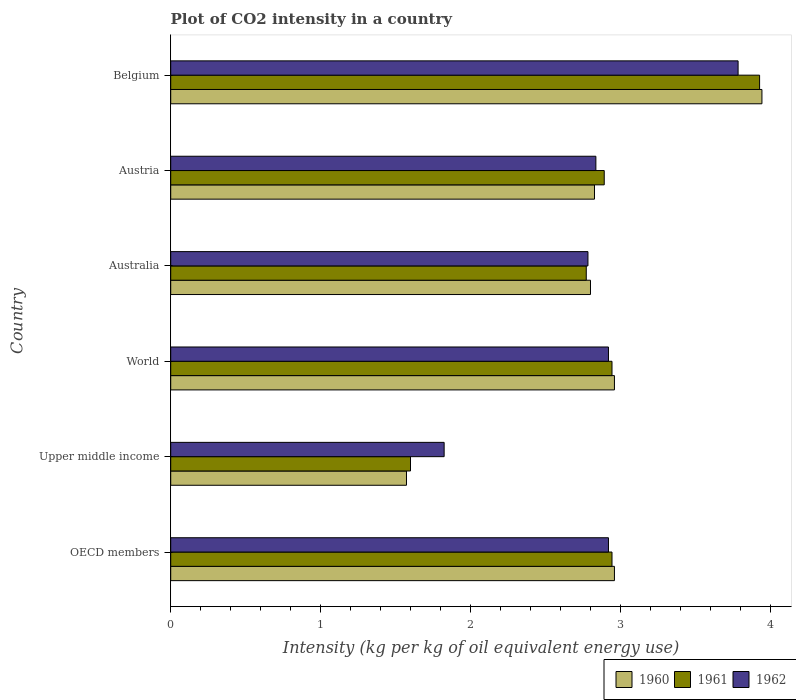How many different coloured bars are there?
Offer a terse response. 3. How many groups of bars are there?
Offer a very short reply. 6. Are the number of bars on each tick of the Y-axis equal?
Provide a succinct answer. Yes. How many bars are there on the 1st tick from the top?
Your answer should be very brief. 3. How many bars are there on the 6th tick from the bottom?
Your response must be concise. 3. What is the label of the 5th group of bars from the top?
Your answer should be compact. Upper middle income. What is the CO2 intensity in in 1962 in Belgium?
Your answer should be very brief. 3.79. Across all countries, what is the maximum CO2 intensity in in 1962?
Your answer should be very brief. 3.79. Across all countries, what is the minimum CO2 intensity in in 1960?
Provide a succinct answer. 1.57. In which country was the CO2 intensity in in 1961 minimum?
Your response must be concise. Upper middle income. What is the total CO2 intensity in in 1962 in the graph?
Offer a very short reply. 17.08. What is the difference between the CO2 intensity in in 1960 in Upper middle income and that in World?
Make the answer very short. -1.39. What is the difference between the CO2 intensity in in 1960 in Austria and the CO2 intensity in in 1962 in Belgium?
Your answer should be compact. -0.96. What is the average CO2 intensity in in 1961 per country?
Keep it short and to the point. 2.85. What is the difference between the CO2 intensity in in 1960 and CO2 intensity in in 1962 in Australia?
Make the answer very short. 0.02. What is the ratio of the CO2 intensity in in 1960 in Australia to that in Belgium?
Provide a succinct answer. 0.71. Is the CO2 intensity in in 1960 in Upper middle income less than that in World?
Make the answer very short. Yes. What is the difference between the highest and the second highest CO2 intensity in in 1961?
Make the answer very short. 0.99. What is the difference between the highest and the lowest CO2 intensity in in 1962?
Your answer should be very brief. 1.96. Is the sum of the CO2 intensity in in 1960 in Belgium and OECD members greater than the maximum CO2 intensity in in 1961 across all countries?
Make the answer very short. Yes. What does the 2nd bar from the top in Belgium represents?
Offer a very short reply. 1961. Is it the case that in every country, the sum of the CO2 intensity in in 1962 and CO2 intensity in in 1960 is greater than the CO2 intensity in in 1961?
Ensure brevity in your answer.  Yes. How many bars are there?
Make the answer very short. 18. Are all the bars in the graph horizontal?
Your answer should be very brief. Yes. How many countries are there in the graph?
Your answer should be very brief. 6. What is the difference between two consecutive major ticks on the X-axis?
Keep it short and to the point. 1. Are the values on the major ticks of X-axis written in scientific E-notation?
Offer a very short reply. No. Does the graph contain any zero values?
Give a very brief answer. No. What is the title of the graph?
Give a very brief answer. Plot of CO2 intensity in a country. Does "1998" appear as one of the legend labels in the graph?
Your response must be concise. No. What is the label or title of the X-axis?
Provide a succinct answer. Intensity (kg per kg of oil equivalent energy use). What is the Intensity (kg per kg of oil equivalent energy use) of 1960 in OECD members?
Your answer should be compact. 2.96. What is the Intensity (kg per kg of oil equivalent energy use) of 1961 in OECD members?
Make the answer very short. 2.95. What is the Intensity (kg per kg of oil equivalent energy use) of 1962 in OECD members?
Offer a very short reply. 2.92. What is the Intensity (kg per kg of oil equivalent energy use) of 1960 in Upper middle income?
Provide a short and direct response. 1.57. What is the Intensity (kg per kg of oil equivalent energy use) of 1961 in Upper middle income?
Your answer should be very brief. 1.6. What is the Intensity (kg per kg of oil equivalent energy use) of 1962 in Upper middle income?
Offer a terse response. 1.82. What is the Intensity (kg per kg of oil equivalent energy use) in 1960 in World?
Offer a very short reply. 2.96. What is the Intensity (kg per kg of oil equivalent energy use) in 1961 in World?
Your answer should be compact. 2.95. What is the Intensity (kg per kg of oil equivalent energy use) of 1962 in World?
Your response must be concise. 2.92. What is the Intensity (kg per kg of oil equivalent energy use) of 1960 in Australia?
Your answer should be compact. 2.8. What is the Intensity (kg per kg of oil equivalent energy use) of 1961 in Australia?
Your response must be concise. 2.77. What is the Intensity (kg per kg of oil equivalent energy use) of 1962 in Australia?
Your answer should be very brief. 2.78. What is the Intensity (kg per kg of oil equivalent energy use) of 1960 in Austria?
Offer a terse response. 2.83. What is the Intensity (kg per kg of oil equivalent energy use) in 1961 in Austria?
Offer a very short reply. 2.89. What is the Intensity (kg per kg of oil equivalent energy use) of 1962 in Austria?
Provide a succinct answer. 2.84. What is the Intensity (kg per kg of oil equivalent energy use) of 1960 in Belgium?
Provide a succinct answer. 3.95. What is the Intensity (kg per kg of oil equivalent energy use) in 1961 in Belgium?
Your answer should be very brief. 3.93. What is the Intensity (kg per kg of oil equivalent energy use) in 1962 in Belgium?
Your response must be concise. 3.79. Across all countries, what is the maximum Intensity (kg per kg of oil equivalent energy use) in 1960?
Your answer should be compact. 3.95. Across all countries, what is the maximum Intensity (kg per kg of oil equivalent energy use) of 1961?
Give a very brief answer. 3.93. Across all countries, what is the maximum Intensity (kg per kg of oil equivalent energy use) in 1962?
Give a very brief answer. 3.79. Across all countries, what is the minimum Intensity (kg per kg of oil equivalent energy use) of 1960?
Keep it short and to the point. 1.57. Across all countries, what is the minimum Intensity (kg per kg of oil equivalent energy use) in 1961?
Make the answer very short. 1.6. Across all countries, what is the minimum Intensity (kg per kg of oil equivalent energy use) in 1962?
Your response must be concise. 1.82. What is the total Intensity (kg per kg of oil equivalent energy use) in 1960 in the graph?
Keep it short and to the point. 17.07. What is the total Intensity (kg per kg of oil equivalent energy use) of 1961 in the graph?
Your answer should be very brief. 17.09. What is the total Intensity (kg per kg of oil equivalent energy use) in 1962 in the graph?
Make the answer very short. 17.08. What is the difference between the Intensity (kg per kg of oil equivalent energy use) of 1960 in OECD members and that in Upper middle income?
Give a very brief answer. 1.39. What is the difference between the Intensity (kg per kg of oil equivalent energy use) in 1961 in OECD members and that in Upper middle income?
Keep it short and to the point. 1.34. What is the difference between the Intensity (kg per kg of oil equivalent energy use) of 1962 in OECD members and that in Upper middle income?
Offer a terse response. 1.1. What is the difference between the Intensity (kg per kg of oil equivalent energy use) in 1961 in OECD members and that in World?
Keep it short and to the point. 0. What is the difference between the Intensity (kg per kg of oil equivalent energy use) of 1960 in OECD members and that in Australia?
Provide a short and direct response. 0.16. What is the difference between the Intensity (kg per kg of oil equivalent energy use) in 1961 in OECD members and that in Australia?
Provide a short and direct response. 0.17. What is the difference between the Intensity (kg per kg of oil equivalent energy use) in 1962 in OECD members and that in Australia?
Your response must be concise. 0.14. What is the difference between the Intensity (kg per kg of oil equivalent energy use) of 1960 in OECD members and that in Austria?
Keep it short and to the point. 0.13. What is the difference between the Intensity (kg per kg of oil equivalent energy use) in 1961 in OECD members and that in Austria?
Your answer should be very brief. 0.05. What is the difference between the Intensity (kg per kg of oil equivalent energy use) of 1962 in OECD members and that in Austria?
Give a very brief answer. 0.08. What is the difference between the Intensity (kg per kg of oil equivalent energy use) of 1960 in OECD members and that in Belgium?
Offer a very short reply. -0.98. What is the difference between the Intensity (kg per kg of oil equivalent energy use) of 1961 in OECD members and that in Belgium?
Give a very brief answer. -0.99. What is the difference between the Intensity (kg per kg of oil equivalent energy use) of 1962 in OECD members and that in Belgium?
Make the answer very short. -0.87. What is the difference between the Intensity (kg per kg of oil equivalent energy use) of 1960 in Upper middle income and that in World?
Offer a very short reply. -1.39. What is the difference between the Intensity (kg per kg of oil equivalent energy use) of 1961 in Upper middle income and that in World?
Your response must be concise. -1.34. What is the difference between the Intensity (kg per kg of oil equivalent energy use) of 1962 in Upper middle income and that in World?
Your response must be concise. -1.1. What is the difference between the Intensity (kg per kg of oil equivalent energy use) of 1960 in Upper middle income and that in Australia?
Provide a succinct answer. -1.23. What is the difference between the Intensity (kg per kg of oil equivalent energy use) of 1961 in Upper middle income and that in Australia?
Offer a terse response. -1.17. What is the difference between the Intensity (kg per kg of oil equivalent energy use) of 1962 in Upper middle income and that in Australia?
Offer a very short reply. -0.96. What is the difference between the Intensity (kg per kg of oil equivalent energy use) in 1960 in Upper middle income and that in Austria?
Your answer should be compact. -1.25. What is the difference between the Intensity (kg per kg of oil equivalent energy use) in 1961 in Upper middle income and that in Austria?
Provide a short and direct response. -1.29. What is the difference between the Intensity (kg per kg of oil equivalent energy use) in 1962 in Upper middle income and that in Austria?
Your answer should be very brief. -1.01. What is the difference between the Intensity (kg per kg of oil equivalent energy use) in 1960 in Upper middle income and that in Belgium?
Keep it short and to the point. -2.37. What is the difference between the Intensity (kg per kg of oil equivalent energy use) in 1961 in Upper middle income and that in Belgium?
Your answer should be compact. -2.33. What is the difference between the Intensity (kg per kg of oil equivalent energy use) in 1962 in Upper middle income and that in Belgium?
Offer a very short reply. -1.96. What is the difference between the Intensity (kg per kg of oil equivalent energy use) of 1960 in World and that in Australia?
Keep it short and to the point. 0.16. What is the difference between the Intensity (kg per kg of oil equivalent energy use) in 1961 in World and that in Australia?
Offer a terse response. 0.17. What is the difference between the Intensity (kg per kg of oil equivalent energy use) in 1962 in World and that in Australia?
Provide a succinct answer. 0.14. What is the difference between the Intensity (kg per kg of oil equivalent energy use) in 1960 in World and that in Austria?
Make the answer very short. 0.13. What is the difference between the Intensity (kg per kg of oil equivalent energy use) of 1961 in World and that in Austria?
Give a very brief answer. 0.05. What is the difference between the Intensity (kg per kg of oil equivalent energy use) of 1962 in World and that in Austria?
Ensure brevity in your answer.  0.08. What is the difference between the Intensity (kg per kg of oil equivalent energy use) in 1960 in World and that in Belgium?
Make the answer very short. -0.98. What is the difference between the Intensity (kg per kg of oil equivalent energy use) in 1961 in World and that in Belgium?
Ensure brevity in your answer.  -0.99. What is the difference between the Intensity (kg per kg of oil equivalent energy use) of 1962 in World and that in Belgium?
Keep it short and to the point. -0.87. What is the difference between the Intensity (kg per kg of oil equivalent energy use) in 1960 in Australia and that in Austria?
Make the answer very short. -0.03. What is the difference between the Intensity (kg per kg of oil equivalent energy use) of 1961 in Australia and that in Austria?
Your response must be concise. -0.12. What is the difference between the Intensity (kg per kg of oil equivalent energy use) of 1962 in Australia and that in Austria?
Your answer should be compact. -0.05. What is the difference between the Intensity (kg per kg of oil equivalent energy use) in 1960 in Australia and that in Belgium?
Your response must be concise. -1.14. What is the difference between the Intensity (kg per kg of oil equivalent energy use) of 1961 in Australia and that in Belgium?
Keep it short and to the point. -1.16. What is the difference between the Intensity (kg per kg of oil equivalent energy use) of 1962 in Australia and that in Belgium?
Your answer should be compact. -1. What is the difference between the Intensity (kg per kg of oil equivalent energy use) in 1960 in Austria and that in Belgium?
Your answer should be compact. -1.12. What is the difference between the Intensity (kg per kg of oil equivalent energy use) of 1961 in Austria and that in Belgium?
Provide a short and direct response. -1.04. What is the difference between the Intensity (kg per kg of oil equivalent energy use) of 1962 in Austria and that in Belgium?
Provide a short and direct response. -0.95. What is the difference between the Intensity (kg per kg of oil equivalent energy use) in 1960 in OECD members and the Intensity (kg per kg of oil equivalent energy use) in 1961 in Upper middle income?
Offer a terse response. 1.36. What is the difference between the Intensity (kg per kg of oil equivalent energy use) of 1960 in OECD members and the Intensity (kg per kg of oil equivalent energy use) of 1962 in Upper middle income?
Offer a terse response. 1.14. What is the difference between the Intensity (kg per kg of oil equivalent energy use) of 1961 in OECD members and the Intensity (kg per kg of oil equivalent energy use) of 1962 in Upper middle income?
Provide a short and direct response. 1.12. What is the difference between the Intensity (kg per kg of oil equivalent energy use) of 1960 in OECD members and the Intensity (kg per kg of oil equivalent energy use) of 1961 in World?
Provide a succinct answer. 0.02. What is the difference between the Intensity (kg per kg of oil equivalent energy use) in 1960 in OECD members and the Intensity (kg per kg of oil equivalent energy use) in 1962 in World?
Provide a short and direct response. 0.04. What is the difference between the Intensity (kg per kg of oil equivalent energy use) of 1961 in OECD members and the Intensity (kg per kg of oil equivalent energy use) of 1962 in World?
Offer a terse response. 0.02. What is the difference between the Intensity (kg per kg of oil equivalent energy use) in 1960 in OECD members and the Intensity (kg per kg of oil equivalent energy use) in 1961 in Australia?
Ensure brevity in your answer.  0.19. What is the difference between the Intensity (kg per kg of oil equivalent energy use) of 1960 in OECD members and the Intensity (kg per kg of oil equivalent energy use) of 1962 in Australia?
Make the answer very short. 0.18. What is the difference between the Intensity (kg per kg of oil equivalent energy use) in 1961 in OECD members and the Intensity (kg per kg of oil equivalent energy use) in 1962 in Australia?
Offer a terse response. 0.16. What is the difference between the Intensity (kg per kg of oil equivalent energy use) in 1960 in OECD members and the Intensity (kg per kg of oil equivalent energy use) in 1961 in Austria?
Offer a terse response. 0.07. What is the difference between the Intensity (kg per kg of oil equivalent energy use) in 1960 in OECD members and the Intensity (kg per kg of oil equivalent energy use) in 1962 in Austria?
Ensure brevity in your answer.  0.12. What is the difference between the Intensity (kg per kg of oil equivalent energy use) of 1961 in OECD members and the Intensity (kg per kg of oil equivalent energy use) of 1962 in Austria?
Ensure brevity in your answer.  0.11. What is the difference between the Intensity (kg per kg of oil equivalent energy use) in 1960 in OECD members and the Intensity (kg per kg of oil equivalent energy use) in 1961 in Belgium?
Your answer should be very brief. -0.97. What is the difference between the Intensity (kg per kg of oil equivalent energy use) of 1960 in OECD members and the Intensity (kg per kg of oil equivalent energy use) of 1962 in Belgium?
Ensure brevity in your answer.  -0.83. What is the difference between the Intensity (kg per kg of oil equivalent energy use) of 1961 in OECD members and the Intensity (kg per kg of oil equivalent energy use) of 1962 in Belgium?
Your answer should be very brief. -0.84. What is the difference between the Intensity (kg per kg of oil equivalent energy use) of 1960 in Upper middle income and the Intensity (kg per kg of oil equivalent energy use) of 1961 in World?
Offer a terse response. -1.37. What is the difference between the Intensity (kg per kg of oil equivalent energy use) in 1960 in Upper middle income and the Intensity (kg per kg of oil equivalent energy use) in 1962 in World?
Your answer should be compact. -1.35. What is the difference between the Intensity (kg per kg of oil equivalent energy use) of 1961 in Upper middle income and the Intensity (kg per kg of oil equivalent energy use) of 1962 in World?
Make the answer very short. -1.32. What is the difference between the Intensity (kg per kg of oil equivalent energy use) in 1960 in Upper middle income and the Intensity (kg per kg of oil equivalent energy use) in 1962 in Australia?
Your answer should be very brief. -1.21. What is the difference between the Intensity (kg per kg of oil equivalent energy use) of 1961 in Upper middle income and the Intensity (kg per kg of oil equivalent energy use) of 1962 in Australia?
Offer a very short reply. -1.18. What is the difference between the Intensity (kg per kg of oil equivalent energy use) in 1960 in Upper middle income and the Intensity (kg per kg of oil equivalent energy use) in 1961 in Austria?
Make the answer very short. -1.32. What is the difference between the Intensity (kg per kg of oil equivalent energy use) of 1960 in Upper middle income and the Intensity (kg per kg of oil equivalent energy use) of 1962 in Austria?
Offer a terse response. -1.26. What is the difference between the Intensity (kg per kg of oil equivalent energy use) of 1961 in Upper middle income and the Intensity (kg per kg of oil equivalent energy use) of 1962 in Austria?
Provide a succinct answer. -1.24. What is the difference between the Intensity (kg per kg of oil equivalent energy use) of 1960 in Upper middle income and the Intensity (kg per kg of oil equivalent energy use) of 1961 in Belgium?
Keep it short and to the point. -2.36. What is the difference between the Intensity (kg per kg of oil equivalent energy use) in 1960 in Upper middle income and the Intensity (kg per kg of oil equivalent energy use) in 1962 in Belgium?
Offer a terse response. -2.21. What is the difference between the Intensity (kg per kg of oil equivalent energy use) of 1961 in Upper middle income and the Intensity (kg per kg of oil equivalent energy use) of 1962 in Belgium?
Your answer should be very brief. -2.19. What is the difference between the Intensity (kg per kg of oil equivalent energy use) of 1960 in World and the Intensity (kg per kg of oil equivalent energy use) of 1961 in Australia?
Your response must be concise. 0.19. What is the difference between the Intensity (kg per kg of oil equivalent energy use) of 1960 in World and the Intensity (kg per kg of oil equivalent energy use) of 1962 in Australia?
Provide a short and direct response. 0.18. What is the difference between the Intensity (kg per kg of oil equivalent energy use) in 1961 in World and the Intensity (kg per kg of oil equivalent energy use) in 1962 in Australia?
Your response must be concise. 0.16. What is the difference between the Intensity (kg per kg of oil equivalent energy use) in 1960 in World and the Intensity (kg per kg of oil equivalent energy use) in 1961 in Austria?
Ensure brevity in your answer.  0.07. What is the difference between the Intensity (kg per kg of oil equivalent energy use) of 1960 in World and the Intensity (kg per kg of oil equivalent energy use) of 1962 in Austria?
Give a very brief answer. 0.12. What is the difference between the Intensity (kg per kg of oil equivalent energy use) in 1961 in World and the Intensity (kg per kg of oil equivalent energy use) in 1962 in Austria?
Your answer should be very brief. 0.11. What is the difference between the Intensity (kg per kg of oil equivalent energy use) in 1960 in World and the Intensity (kg per kg of oil equivalent energy use) in 1961 in Belgium?
Offer a terse response. -0.97. What is the difference between the Intensity (kg per kg of oil equivalent energy use) of 1960 in World and the Intensity (kg per kg of oil equivalent energy use) of 1962 in Belgium?
Your answer should be very brief. -0.83. What is the difference between the Intensity (kg per kg of oil equivalent energy use) in 1961 in World and the Intensity (kg per kg of oil equivalent energy use) in 1962 in Belgium?
Offer a very short reply. -0.84. What is the difference between the Intensity (kg per kg of oil equivalent energy use) of 1960 in Australia and the Intensity (kg per kg of oil equivalent energy use) of 1961 in Austria?
Make the answer very short. -0.09. What is the difference between the Intensity (kg per kg of oil equivalent energy use) in 1960 in Australia and the Intensity (kg per kg of oil equivalent energy use) in 1962 in Austria?
Provide a short and direct response. -0.04. What is the difference between the Intensity (kg per kg of oil equivalent energy use) in 1961 in Australia and the Intensity (kg per kg of oil equivalent energy use) in 1962 in Austria?
Your answer should be compact. -0.06. What is the difference between the Intensity (kg per kg of oil equivalent energy use) of 1960 in Australia and the Intensity (kg per kg of oil equivalent energy use) of 1961 in Belgium?
Make the answer very short. -1.13. What is the difference between the Intensity (kg per kg of oil equivalent energy use) of 1960 in Australia and the Intensity (kg per kg of oil equivalent energy use) of 1962 in Belgium?
Your answer should be very brief. -0.99. What is the difference between the Intensity (kg per kg of oil equivalent energy use) of 1961 in Australia and the Intensity (kg per kg of oil equivalent energy use) of 1962 in Belgium?
Provide a succinct answer. -1.01. What is the difference between the Intensity (kg per kg of oil equivalent energy use) of 1960 in Austria and the Intensity (kg per kg of oil equivalent energy use) of 1961 in Belgium?
Provide a succinct answer. -1.1. What is the difference between the Intensity (kg per kg of oil equivalent energy use) of 1960 in Austria and the Intensity (kg per kg of oil equivalent energy use) of 1962 in Belgium?
Ensure brevity in your answer.  -0.96. What is the difference between the Intensity (kg per kg of oil equivalent energy use) of 1961 in Austria and the Intensity (kg per kg of oil equivalent energy use) of 1962 in Belgium?
Offer a terse response. -0.89. What is the average Intensity (kg per kg of oil equivalent energy use) of 1960 per country?
Your answer should be very brief. 2.85. What is the average Intensity (kg per kg of oil equivalent energy use) in 1961 per country?
Make the answer very short. 2.85. What is the average Intensity (kg per kg of oil equivalent energy use) of 1962 per country?
Provide a succinct answer. 2.85. What is the difference between the Intensity (kg per kg of oil equivalent energy use) in 1960 and Intensity (kg per kg of oil equivalent energy use) in 1961 in OECD members?
Make the answer very short. 0.02. What is the difference between the Intensity (kg per kg of oil equivalent energy use) of 1960 and Intensity (kg per kg of oil equivalent energy use) of 1962 in OECD members?
Your answer should be compact. 0.04. What is the difference between the Intensity (kg per kg of oil equivalent energy use) in 1961 and Intensity (kg per kg of oil equivalent energy use) in 1962 in OECD members?
Provide a short and direct response. 0.02. What is the difference between the Intensity (kg per kg of oil equivalent energy use) in 1960 and Intensity (kg per kg of oil equivalent energy use) in 1961 in Upper middle income?
Keep it short and to the point. -0.03. What is the difference between the Intensity (kg per kg of oil equivalent energy use) of 1960 and Intensity (kg per kg of oil equivalent energy use) of 1962 in Upper middle income?
Provide a short and direct response. -0.25. What is the difference between the Intensity (kg per kg of oil equivalent energy use) in 1961 and Intensity (kg per kg of oil equivalent energy use) in 1962 in Upper middle income?
Offer a terse response. -0.22. What is the difference between the Intensity (kg per kg of oil equivalent energy use) of 1960 and Intensity (kg per kg of oil equivalent energy use) of 1961 in World?
Your answer should be very brief. 0.02. What is the difference between the Intensity (kg per kg of oil equivalent energy use) of 1960 and Intensity (kg per kg of oil equivalent energy use) of 1962 in World?
Provide a short and direct response. 0.04. What is the difference between the Intensity (kg per kg of oil equivalent energy use) of 1961 and Intensity (kg per kg of oil equivalent energy use) of 1962 in World?
Make the answer very short. 0.02. What is the difference between the Intensity (kg per kg of oil equivalent energy use) in 1960 and Intensity (kg per kg of oil equivalent energy use) in 1961 in Australia?
Ensure brevity in your answer.  0.03. What is the difference between the Intensity (kg per kg of oil equivalent energy use) in 1960 and Intensity (kg per kg of oil equivalent energy use) in 1962 in Australia?
Give a very brief answer. 0.02. What is the difference between the Intensity (kg per kg of oil equivalent energy use) in 1961 and Intensity (kg per kg of oil equivalent energy use) in 1962 in Australia?
Your answer should be compact. -0.01. What is the difference between the Intensity (kg per kg of oil equivalent energy use) in 1960 and Intensity (kg per kg of oil equivalent energy use) in 1961 in Austria?
Your response must be concise. -0.07. What is the difference between the Intensity (kg per kg of oil equivalent energy use) in 1960 and Intensity (kg per kg of oil equivalent energy use) in 1962 in Austria?
Offer a very short reply. -0.01. What is the difference between the Intensity (kg per kg of oil equivalent energy use) in 1961 and Intensity (kg per kg of oil equivalent energy use) in 1962 in Austria?
Make the answer very short. 0.06. What is the difference between the Intensity (kg per kg of oil equivalent energy use) of 1960 and Intensity (kg per kg of oil equivalent energy use) of 1961 in Belgium?
Make the answer very short. 0.02. What is the difference between the Intensity (kg per kg of oil equivalent energy use) in 1960 and Intensity (kg per kg of oil equivalent energy use) in 1962 in Belgium?
Provide a succinct answer. 0.16. What is the difference between the Intensity (kg per kg of oil equivalent energy use) in 1961 and Intensity (kg per kg of oil equivalent energy use) in 1962 in Belgium?
Your answer should be very brief. 0.14. What is the ratio of the Intensity (kg per kg of oil equivalent energy use) of 1960 in OECD members to that in Upper middle income?
Your answer should be very brief. 1.88. What is the ratio of the Intensity (kg per kg of oil equivalent energy use) of 1961 in OECD members to that in Upper middle income?
Your answer should be compact. 1.84. What is the ratio of the Intensity (kg per kg of oil equivalent energy use) of 1962 in OECD members to that in Upper middle income?
Offer a very short reply. 1.6. What is the ratio of the Intensity (kg per kg of oil equivalent energy use) in 1961 in OECD members to that in World?
Keep it short and to the point. 1. What is the ratio of the Intensity (kg per kg of oil equivalent energy use) in 1960 in OECD members to that in Australia?
Keep it short and to the point. 1.06. What is the ratio of the Intensity (kg per kg of oil equivalent energy use) in 1961 in OECD members to that in Australia?
Offer a terse response. 1.06. What is the ratio of the Intensity (kg per kg of oil equivalent energy use) in 1962 in OECD members to that in Australia?
Make the answer very short. 1.05. What is the ratio of the Intensity (kg per kg of oil equivalent energy use) of 1960 in OECD members to that in Austria?
Your response must be concise. 1.05. What is the ratio of the Intensity (kg per kg of oil equivalent energy use) of 1961 in OECD members to that in Austria?
Provide a succinct answer. 1.02. What is the ratio of the Intensity (kg per kg of oil equivalent energy use) of 1962 in OECD members to that in Austria?
Provide a short and direct response. 1.03. What is the ratio of the Intensity (kg per kg of oil equivalent energy use) in 1960 in OECD members to that in Belgium?
Your response must be concise. 0.75. What is the ratio of the Intensity (kg per kg of oil equivalent energy use) in 1961 in OECD members to that in Belgium?
Provide a short and direct response. 0.75. What is the ratio of the Intensity (kg per kg of oil equivalent energy use) of 1962 in OECD members to that in Belgium?
Your answer should be compact. 0.77. What is the ratio of the Intensity (kg per kg of oil equivalent energy use) of 1960 in Upper middle income to that in World?
Offer a very short reply. 0.53. What is the ratio of the Intensity (kg per kg of oil equivalent energy use) of 1961 in Upper middle income to that in World?
Your response must be concise. 0.54. What is the ratio of the Intensity (kg per kg of oil equivalent energy use) in 1962 in Upper middle income to that in World?
Your response must be concise. 0.62. What is the ratio of the Intensity (kg per kg of oil equivalent energy use) in 1960 in Upper middle income to that in Australia?
Provide a short and direct response. 0.56. What is the ratio of the Intensity (kg per kg of oil equivalent energy use) in 1961 in Upper middle income to that in Australia?
Your response must be concise. 0.58. What is the ratio of the Intensity (kg per kg of oil equivalent energy use) in 1962 in Upper middle income to that in Australia?
Your answer should be very brief. 0.66. What is the ratio of the Intensity (kg per kg of oil equivalent energy use) of 1960 in Upper middle income to that in Austria?
Your answer should be very brief. 0.56. What is the ratio of the Intensity (kg per kg of oil equivalent energy use) in 1961 in Upper middle income to that in Austria?
Offer a terse response. 0.55. What is the ratio of the Intensity (kg per kg of oil equivalent energy use) of 1962 in Upper middle income to that in Austria?
Your answer should be very brief. 0.64. What is the ratio of the Intensity (kg per kg of oil equivalent energy use) in 1960 in Upper middle income to that in Belgium?
Your answer should be very brief. 0.4. What is the ratio of the Intensity (kg per kg of oil equivalent energy use) of 1961 in Upper middle income to that in Belgium?
Offer a terse response. 0.41. What is the ratio of the Intensity (kg per kg of oil equivalent energy use) of 1962 in Upper middle income to that in Belgium?
Keep it short and to the point. 0.48. What is the ratio of the Intensity (kg per kg of oil equivalent energy use) of 1960 in World to that in Australia?
Provide a succinct answer. 1.06. What is the ratio of the Intensity (kg per kg of oil equivalent energy use) of 1961 in World to that in Australia?
Provide a succinct answer. 1.06. What is the ratio of the Intensity (kg per kg of oil equivalent energy use) in 1962 in World to that in Australia?
Offer a very short reply. 1.05. What is the ratio of the Intensity (kg per kg of oil equivalent energy use) of 1960 in World to that in Austria?
Your response must be concise. 1.05. What is the ratio of the Intensity (kg per kg of oil equivalent energy use) in 1961 in World to that in Austria?
Give a very brief answer. 1.02. What is the ratio of the Intensity (kg per kg of oil equivalent energy use) in 1962 in World to that in Austria?
Offer a very short reply. 1.03. What is the ratio of the Intensity (kg per kg of oil equivalent energy use) in 1960 in World to that in Belgium?
Give a very brief answer. 0.75. What is the ratio of the Intensity (kg per kg of oil equivalent energy use) in 1961 in World to that in Belgium?
Offer a terse response. 0.75. What is the ratio of the Intensity (kg per kg of oil equivalent energy use) in 1962 in World to that in Belgium?
Provide a short and direct response. 0.77. What is the ratio of the Intensity (kg per kg of oil equivalent energy use) in 1960 in Australia to that in Austria?
Ensure brevity in your answer.  0.99. What is the ratio of the Intensity (kg per kg of oil equivalent energy use) in 1961 in Australia to that in Austria?
Your answer should be compact. 0.96. What is the ratio of the Intensity (kg per kg of oil equivalent energy use) in 1962 in Australia to that in Austria?
Your answer should be compact. 0.98. What is the ratio of the Intensity (kg per kg of oil equivalent energy use) of 1960 in Australia to that in Belgium?
Your answer should be compact. 0.71. What is the ratio of the Intensity (kg per kg of oil equivalent energy use) in 1961 in Australia to that in Belgium?
Give a very brief answer. 0.71. What is the ratio of the Intensity (kg per kg of oil equivalent energy use) in 1962 in Australia to that in Belgium?
Give a very brief answer. 0.74. What is the ratio of the Intensity (kg per kg of oil equivalent energy use) of 1960 in Austria to that in Belgium?
Offer a very short reply. 0.72. What is the ratio of the Intensity (kg per kg of oil equivalent energy use) of 1961 in Austria to that in Belgium?
Make the answer very short. 0.74. What is the ratio of the Intensity (kg per kg of oil equivalent energy use) in 1962 in Austria to that in Belgium?
Your answer should be very brief. 0.75. What is the difference between the highest and the second highest Intensity (kg per kg of oil equivalent energy use) of 1960?
Offer a terse response. 0.98. What is the difference between the highest and the second highest Intensity (kg per kg of oil equivalent energy use) of 1961?
Your response must be concise. 0.99. What is the difference between the highest and the second highest Intensity (kg per kg of oil equivalent energy use) in 1962?
Ensure brevity in your answer.  0.87. What is the difference between the highest and the lowest Intensity (kg per kg of oil equivalent energy use) of 1960?
Keep it short and to the point. 2.37. What is the difference between the highest and the lowest Intensity (kg per kg of oil equivalent energy use) of 1961?
Give a very brief answer. 2.33. What is the difference between the highest and the lowest Intensity (kg per kg of oil equivalent energy use) in 1962?
Offer a very short reply. 1.96. 